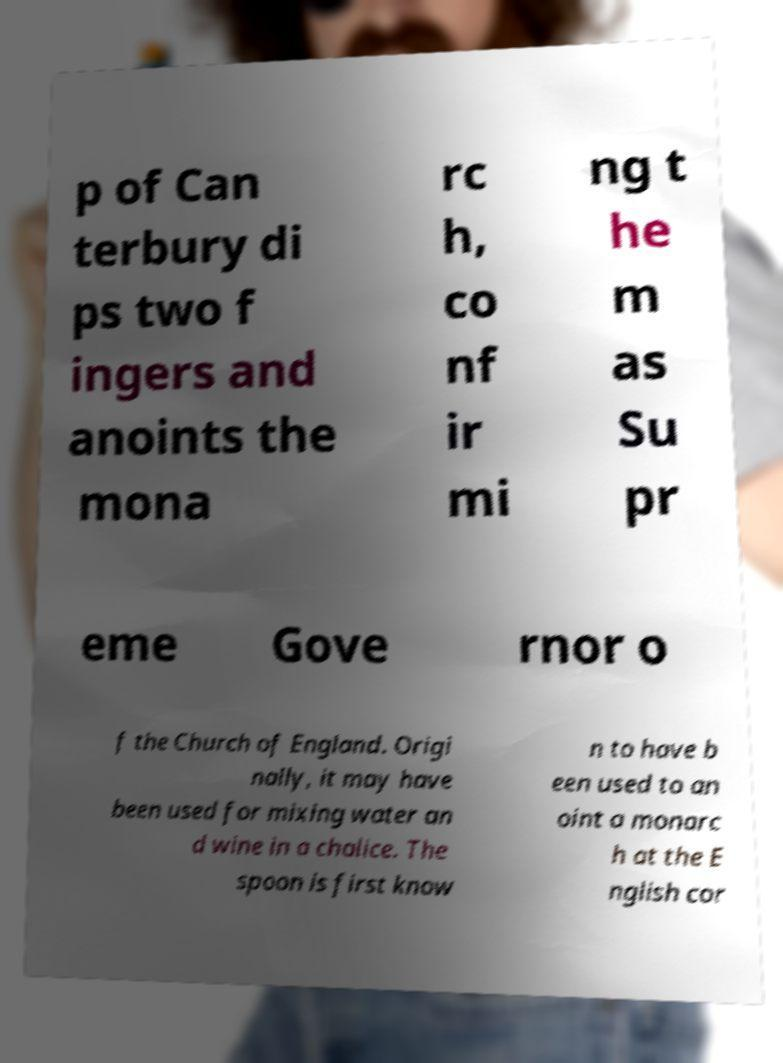Please read and relay the text visible in this image. What does it say? p of Can terbury di ps two f ingers and anoints the mona rc h, co nf ir mi ng t he m as Su pr eme Gove rnor o f the Church of England. Origi nally, it may have been used for mixing water an d wine in a chalice. The spoon is first know n to have b een used to an oint a monarc h at the E nglish cor 